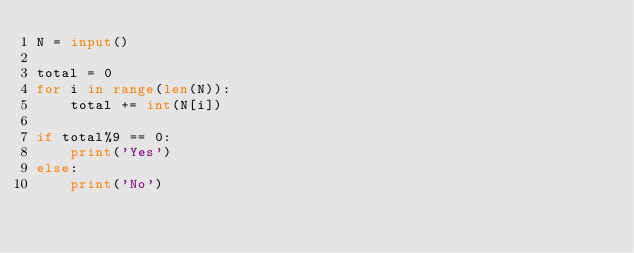<code> <loc_0><loc_0><loc_500><loc_500><_Python_>N = input()

total = 0
for i in range(len(N)):
    total += int(N[i])

if total%9 == 0:
    print('Yes')
else:
    print('No')</code> 